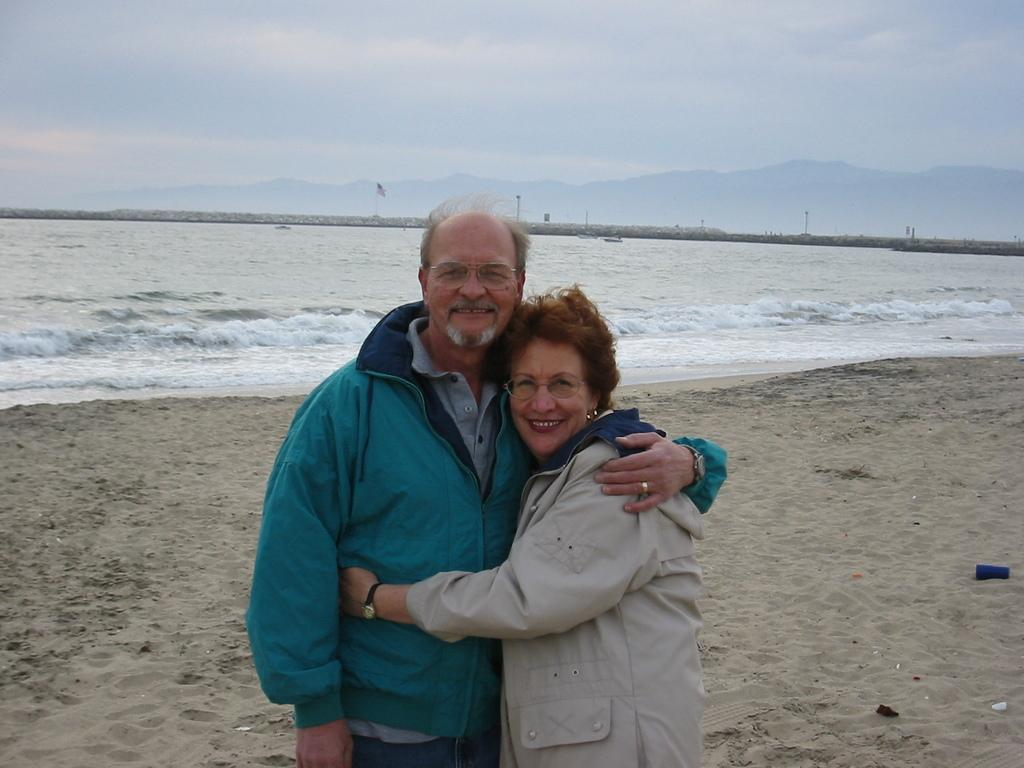How many people are present in the image? There are two people, a man and a woman, present in the image. What are the man and woman doing in the image? The man and woman are standing in the image. What can be seen in the background of the image? There is a hill and a blue and cloudy sky visible in the background of the image. What is the flag associated with in the image? The flag's association is not specified in the image. What type of blade is being used by the man in the image? There is no blade present in the image; the man and woman are simply standing. 